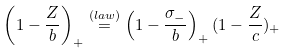<formula> <loc_0><loc_0><loc_500><loc_500>\left ( 1 - \frac { Z } { b } \right ) _ { + } \stackrel { ( l a w ) } { = } \left ( 1 - \frac { \sigma _ { - } } { b } \right ) _ { + } ( 1 - \frac { Z } { c } ) _ { + }</formula> 